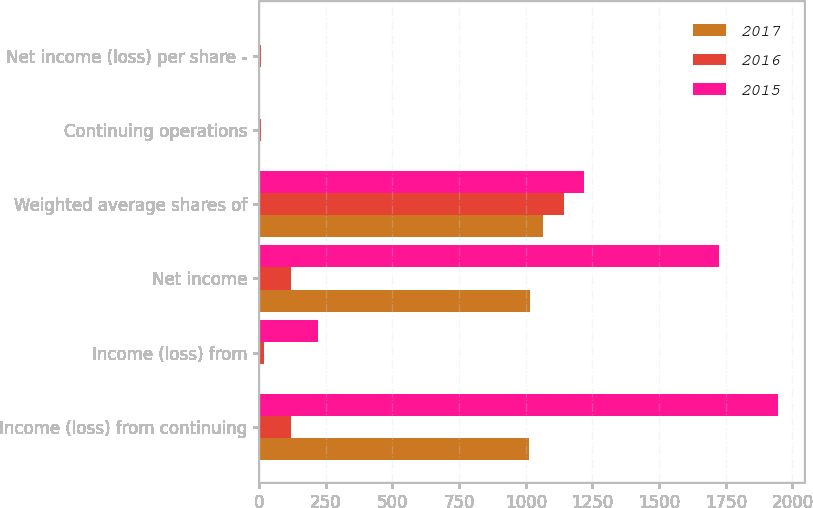Convert chart. <chart><loc_0><loc_0><loc_500><loc_500><stacked_bar_chart><ecel><fcel>Income (loss) from continuing<fcel>Income (loss) from<fcel>Net income<fcel>Weighted average shares of<fcel>Continuing operations<fcel>Net income (loss) per share -<nl><fcel>2017<fcel>1012<fcel>4<fcel>1016<fcel>1064<fcel>0.95<fcel>0.95<nl><fcel>2016<fcel>120.5<fcel>19<fcel>120.5<fcel>1144<fcel>6.43<fcel>6.35<nl><fcel>2015<fcel>1947<fcel>222<fcel>1725<fcel>1220<fcel>1.61<fcel>1.42<nl></chart> 